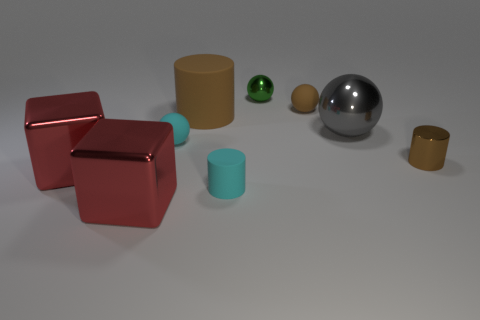Subtract all brown cylinders. Subtract all red balls. How many cylinders are left? 1 Add 1 tiny green objects. How many objects exist? 10 Subtract all cubes. How many objects are left? 7 Subtract all green metallic spheres. Subtract all gray balls. How many objects are left? 7 Add 7 large rubber things. How many large rubber things are left? 8 Add 7 blue matte cubes. How many blue matte cubes exist? 7 Subtract 0 cyan blocks. How many objects are left? 9 